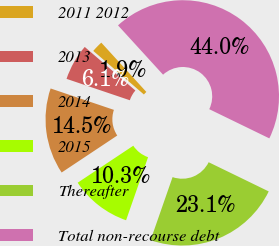Convert chart. <chart><loc_0><loc_0><loc_500><loc_500><pie_chart><fcel>2011 2012<fcel>2013<fcel>2014<fcel>2015<fcel>Thereafter<fcel>Total non-recourse debt<nl><fcel>1.91%<fcel>6.12%<fcel>14.53%<fcel>10.32%<fcel>23.14%<fcel>43.98%<nl></chart> 